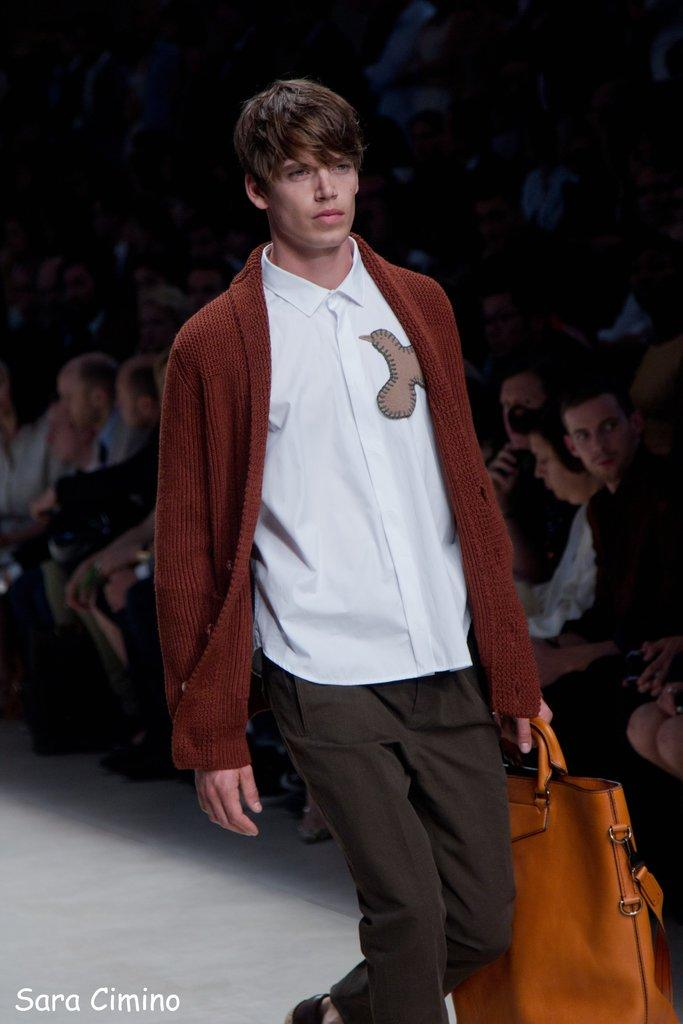Who is the main subject in the image? There is a man in the image. What is the man holding in his hand? The man is carrying a bag in his hand. What surface is the man walking on? The man is walking on a ramp. Who else is present in the image? There is a group of people beside the man. What are the group of people doing? The group of people are viewing the man. What time of day is it in the image, considering the presence of morning light? There is no mention of morning light or any specific time of day in the image. The time of day cannot be determined from the provided facts. 